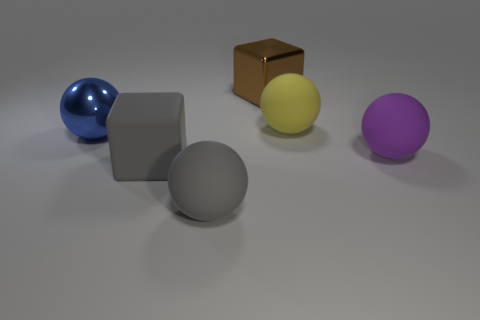Subtract all large matte spheres. How many spheres are left? 1 Subtract 1 balls. How many balls are left? 3 Subtract all red balls. Subtract all purple blocks. How many balls are left? 4 Add 1 small gray cubes. How many objects exist? 7 Subtract all blocks. How many objects are left? 4 Add 6 metallic spheres. How many metallic spheres exist? 7 Subtract 0 purple cylinders. How many objects are left? 6 Subtract all gray things. Subtract all big shiny spheres. How many objects are left? 3 Add 1 big gray rubber blocks. How many big gray rubber blocks are left? 2 